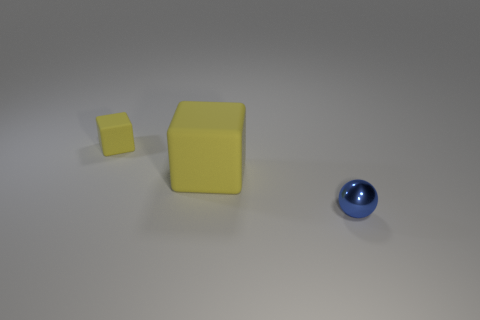How many other things are the same color as the big matte block?
Your answer should be compact. 1. Are there fewer tiny blue balls that are to the left of the metal ball than balls on the left side of the large yellow rubber object?
Give a very brief answer. No. Does the small matte block have the same color as the large matte object?
Your answer should be compact. Yes. Are there fewer objects behind the ball than objects?
Your answer should be very brief. Yes. Are the tiny cube and the large cube made of the same material?
Keep it short and to the point. Yes. What number of small red spheres are the same material as the tiny yellow object?
Your response must be concise. 0. There is a large block that is made of the same material as the small yellow thing; what color is it?
Give a very brief answer. Yellow. What is the shape of the blue shiny thing?
Provide a short and direct response. Sphere. What is the material of the cube that is behind the large yellow object?
Ensure brevity in your answer.  Rubber. Is there a large cube that has the same color as the small rubber thing?
Your answer should be compact. Yes. 